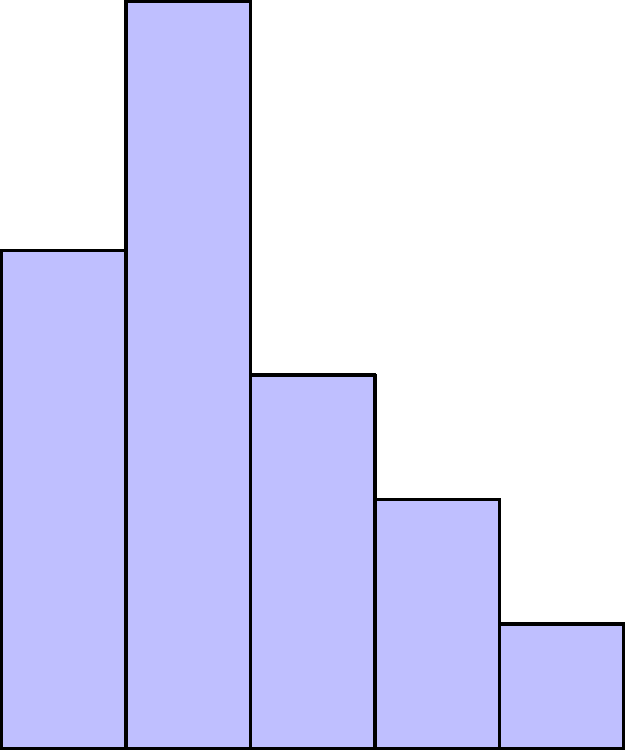A parent strictly schedules their child's daily routine as shown in the bar graph. If the parent decides to increase the time spent on each activity by 20%, what will be the new total time spent on structured activities? Use calculus to solve this problem. To solve this problem using calculus, we'll follow these steps:

1) First, let's identify the current time spent on each activity:
   Homework: 2 hours
   Chores: 3 hours
   Reading: 1.5 hours
   Sports: 1 hour
   Free Time: 0.5 hours

2) The total current time is the sum of these values. We can represent this as an integral:

   $$\int_0^5 f(x) dx$$

   where $f(x)$ is a step function representing the height of each bar.

3) To calculate this integral, we sum the areas of each rectangle:

   $$\text{Total} = 2 + 3 + 1.5 + 1 + 0.5 = 8 \text{ hours}$$

4) Now, if we increase each activity by 20%, we're essentially scaling our function by 1.2:

   $$\text{New Total} = \int_0^5 1.2f(x) dx$$

5) Due to the linearity of integrals, this is equivalent to:

   $$\text{New Total} = 1.2 \int_0^5 f(x) dx = 1.2 * 8 = 9.6 \text{ hours}$$

Therefore, after increasing each activity by 20%, the new total time spent on structured activities will be 9.6 hours.
Answer: 9.6 hours 